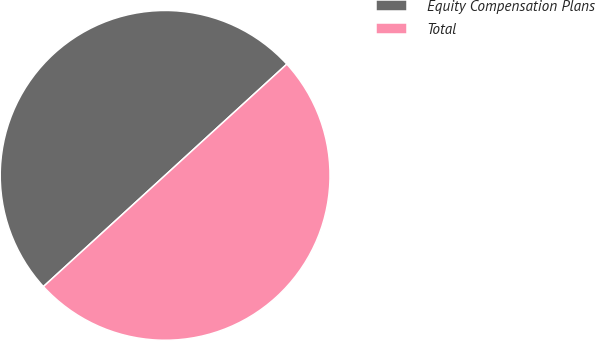<chart> <loc_0><loc_0><loc_500><loc_500><pie_chart><fcel>Equity Compensation Plans<fcel>Total<nl><fcel>50.0%<fcel>50.0%<nl></chart> 